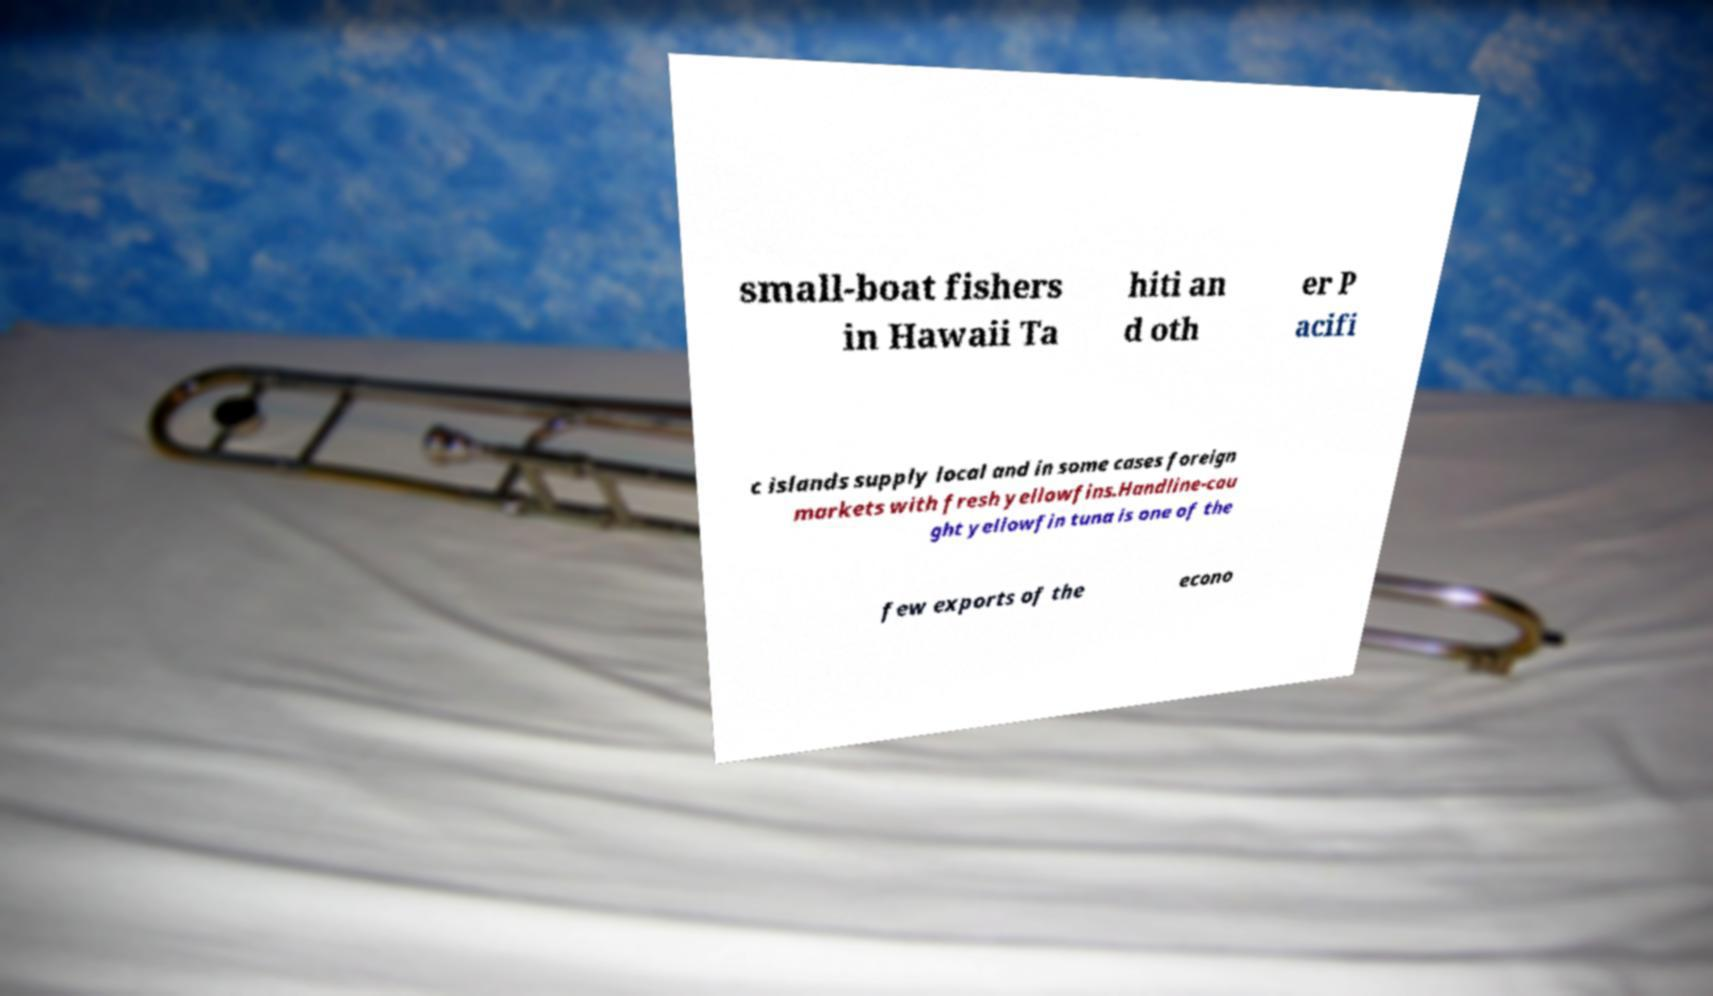I need the written content from this picture converted into text. Can you do that? small-boat fishers in Hawaii Ta hiti an d oth er P acifi c islands supply local and in some cases foreign markets with fresh yellowfins.Handline-cau ght yellowfin tuna is one of the few exports of the econo 